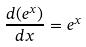<formula> <loc_0><loc_0><loc_500><loc_500>\frac { d ( e ^ { x } ) } { d x } = e ^ { x }</formula> 